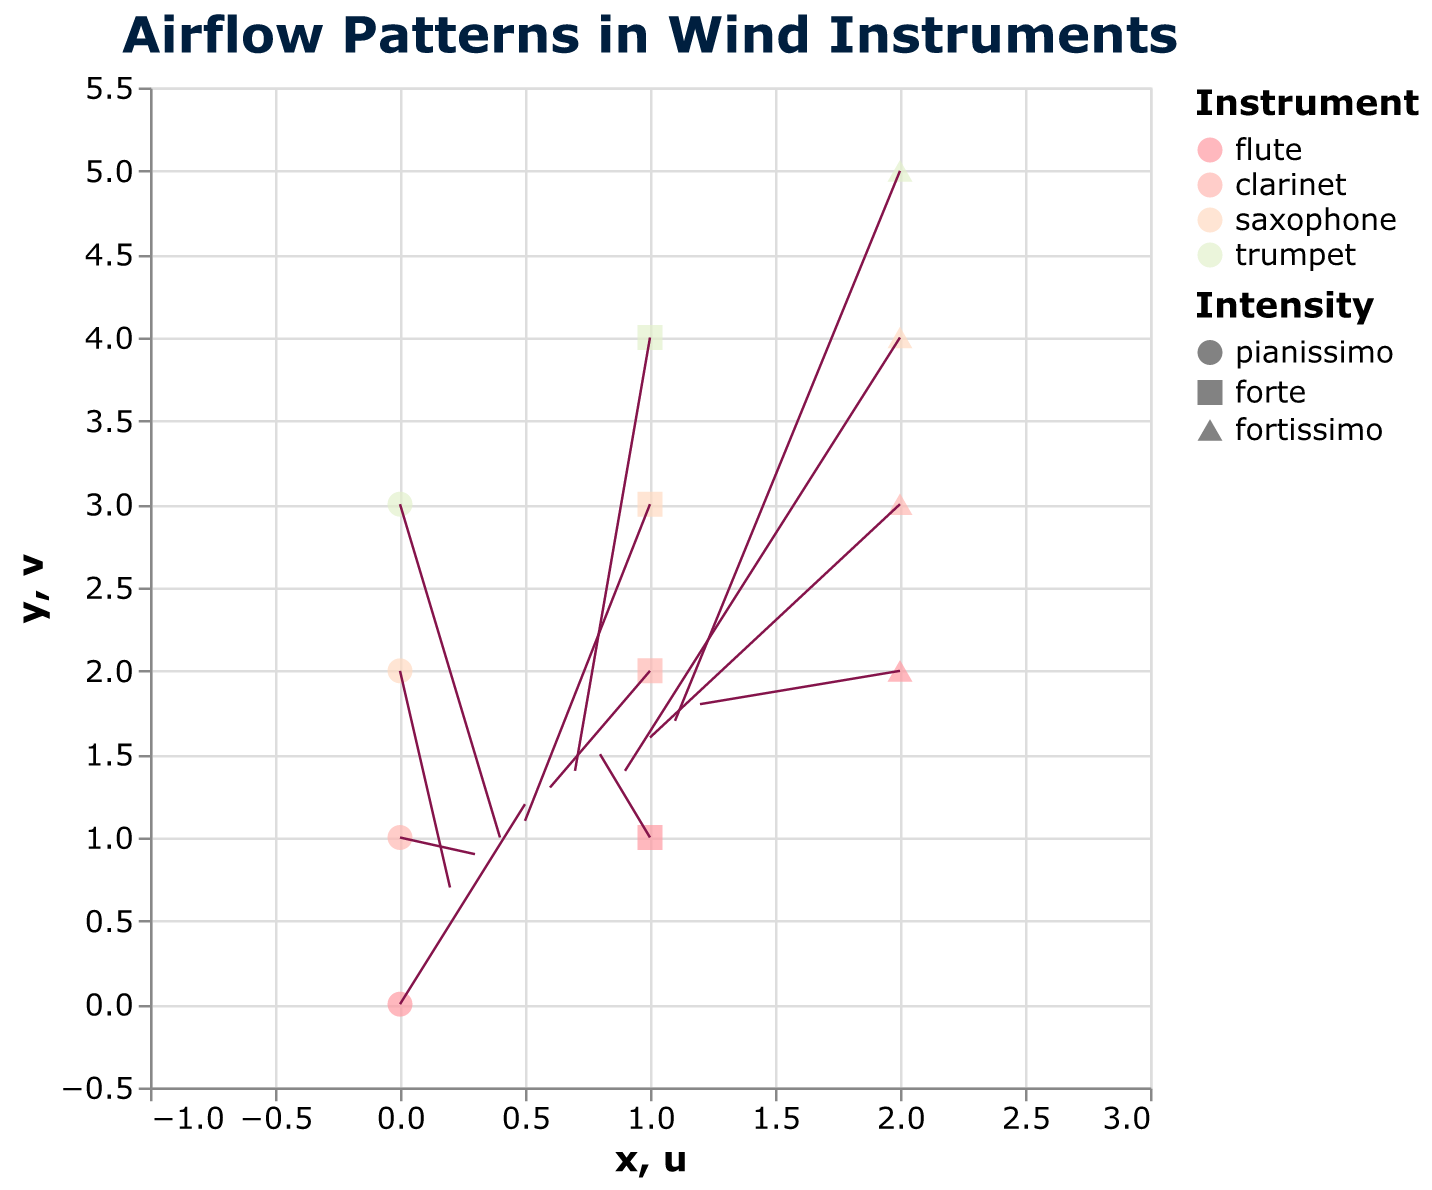What is the color used to represent the trumpet? The color representing the trumpet is assigned based on the 'instrument' field, with the trumpet being shown in a soft green shade.
Answer: Soft green Which instrument has the longest airflow vector at fortissimo intensity? By examining the length of the arrows (representing airflow vectors) at "fortissimo" intensity, the longest vector belongs to the flute and is measured from (2, 2) to (1.2, 1.8).
Answer: Flute Compare the airflow vector lengths between pianissimo and fortissimo intensities for the clarinet. Which is longer? For the clarinet at pianissimo, the vector is from (0, 1) to (0.3, 0.9). At fortissimo, the vector is from (2, 3) to (1, 1.6). By visually comparing the arrow lengths, the fortissimo vector is longer.
Answer: Fortissimo How does the airflow intensity change from pianissimo to forte for the saxophone? For the saxophone, at pianissimo (0, 2), the vector is from (0.2, 0.7). At forte (1, 3), it extends to (0.5, 1.1). The increase in both u and v components indicates a stronger airflow at forte.
Answer: It increases What shape is used to represent forte intensity for the trumpet? The shape encoding for intensity shows forte represented with a square. Therefore, the trumpet at forte is shown with a square shape.
Answer: Square Is the airflow more intense in the flute or saxophone at pianissimo? By comparing airflow vectors of the flute at (0, 0) and saxophone at (0, 2) for pianissimo, the flute's vector (0.5, 1.2) is stronger than the saxophone's (0.2, 0.7).
Answer: Flute What is the average length of the airflow vectors for the clarinet across all intensities? For the clarinet, at pianissimo, the vector length is sqrt(0.3^2 + 0.9^2) = 0.948; at forte, it's sqrt(0.6^2 + 1.3^2) = 1.418; and at fortissimo, it's sqrt(1.0^2 + 1.6^2) = 1.886. The average is (0.948 + 1.418 + 1.886) / 3 = 1.417.
Answer: 1.417 Which instrument has the shortest airflow vector at forte intensity? By examining the vectors at forte intensity, the saxophone at (1, 3) has the shortest vector, which extends to (0.5, 1.1).
Answer: Saxophone 